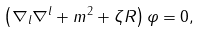Convert formula to latex. <formula><loc_0><loc_0><loc_500><loc_500>\left ( \nabla _ { l } \nabla ^ { l } + m ^ { 2 } + \zeta R \right ) \varphi = 0 ,</formula> 